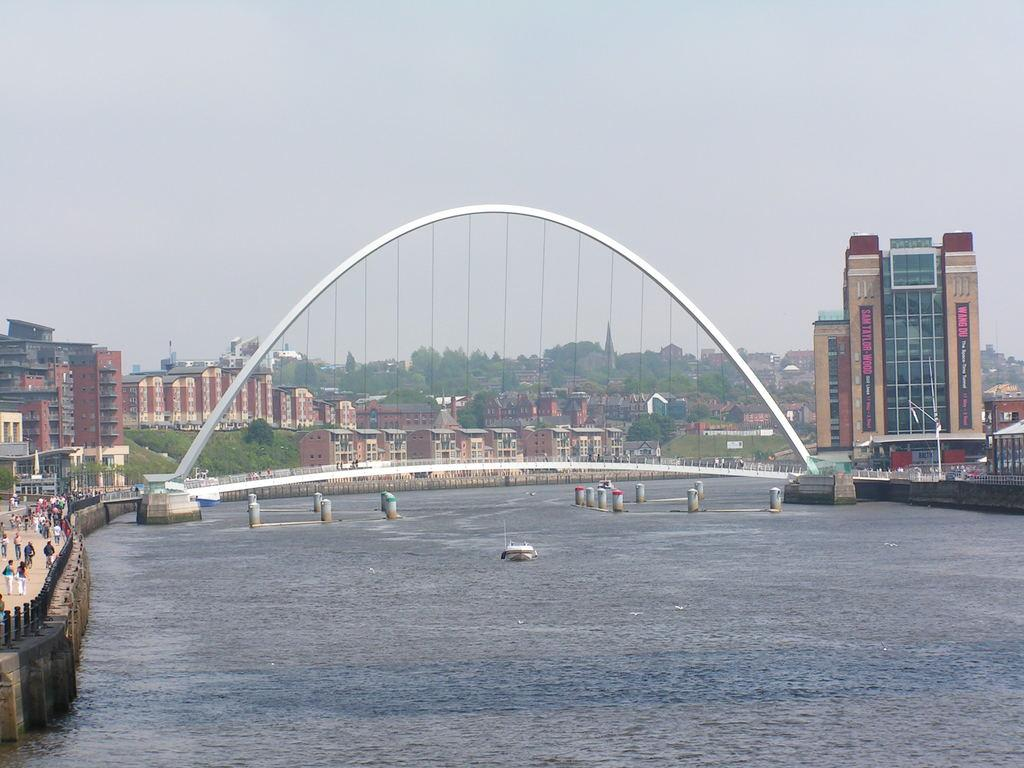What type of structures can be seen in the image? There are buildings in the image. What natural elements are present in the image? There are trees and water visible in the image. What man-made feature connects the two sides of the water? There is a bridge in the image. What is the boat used for in the image? The boat is likely used for transportation or leisure on the water. What part of the natural environment is visible in the image? The sky is visible in the image. What type of flowers can be seen growing on the bridge in the image? There are no flowers visible on the bridge in the image. How does the tooth feel about being in the image? There is no tooth present in the image, so it cannot have any feelings about being in the image. 